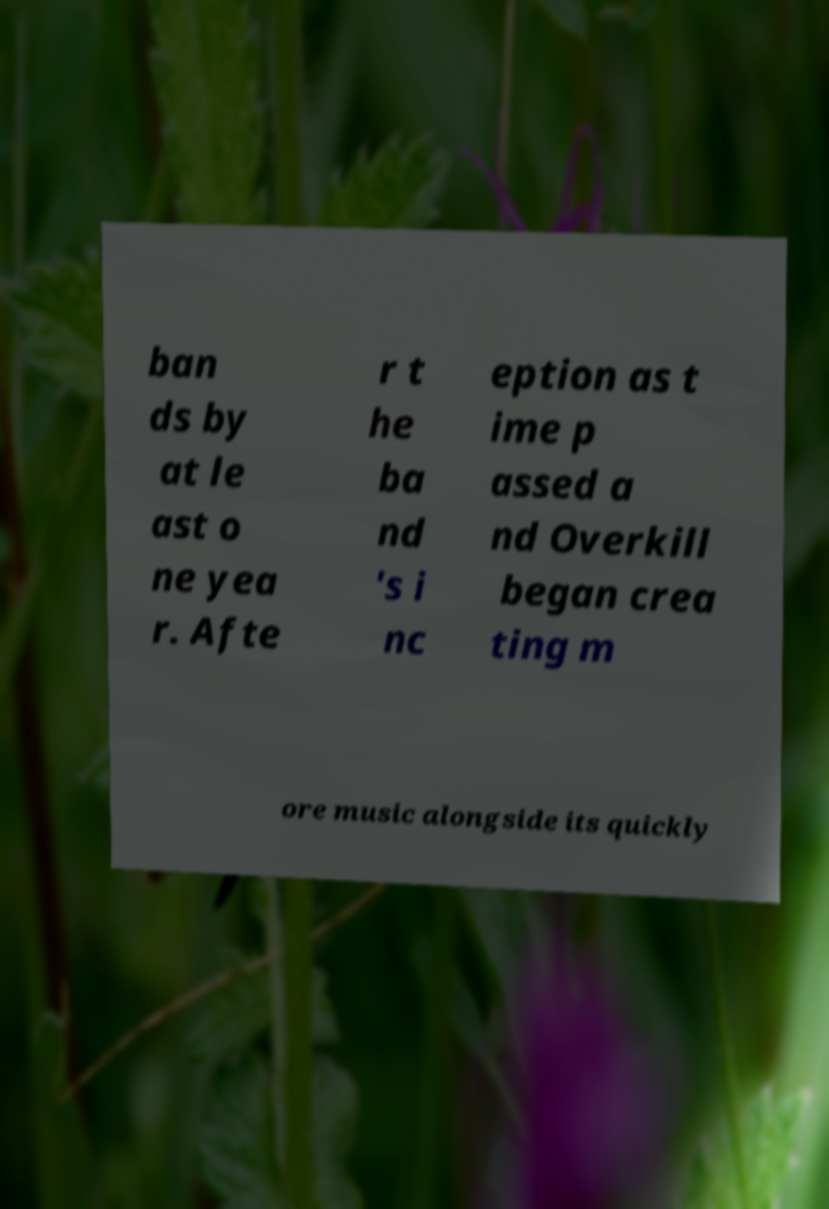Can you read and provide the text displayed in the image?This photo seems to have some interesting text. Can you extract and type it out for me? ban ds by at le ast o ne yea r. Afte r t he ba nd 's i nc eption as t ime p assed a nd Overkill began crea ting m ore music alongside its quickly 